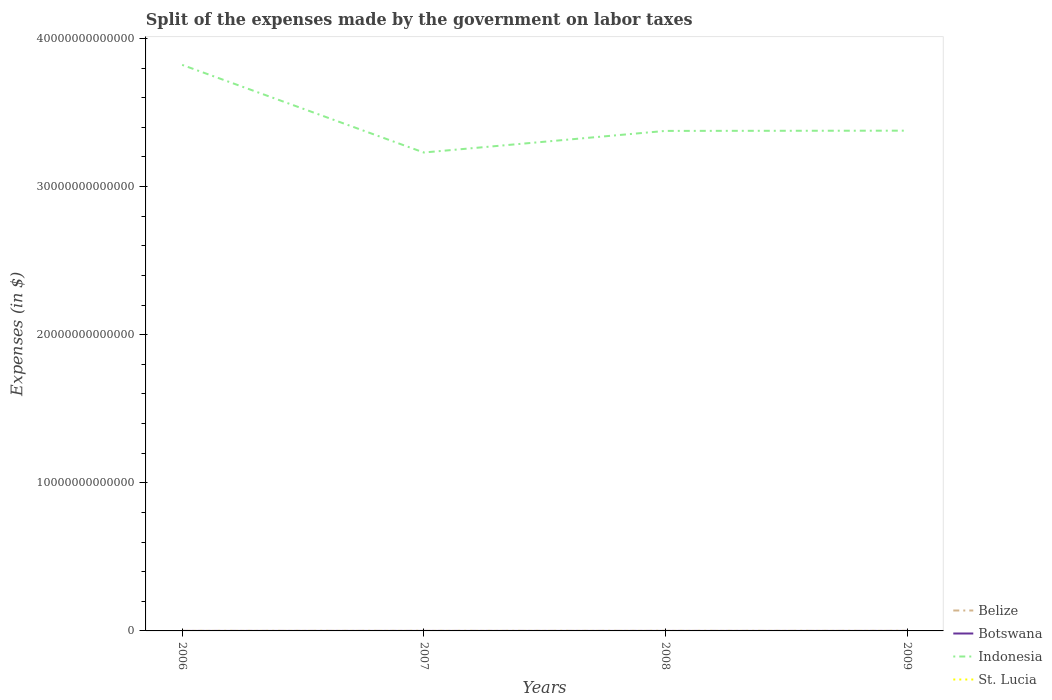Is the number of lines equal to the number of legend labels?
Provide a short and direct response. Yes. Across all years, what is the maximum expenses made by the government on labor taxes in Belize?
Keep it short and to the point. 4.30e+06. In which year was the expenses made by the government on labor taxes in Indonesia maximum?
Your answer should be very brief. 2007. What is the total expenses made by the government on labor taxes in Belize in the graph?
Your response must be concise. -9.65e+05. What is the difference between the highest and the second highest expenses made by the government on labor taxes in Botswana?
Your answer should be very brief. 1.55e+07. What is the difference between the highest and the lowest expenses made by the government on labor taxes in St. Lucia?
Keep it short and to the point. 3. Is the expenses made by the government on labor taxes in St. Lucia strictly greater than the expenses made by the government on labor taxes in Botswana over the years?
Offer a very short reply. Yes. How many years are there in the graph?
Your response must be concise. 4. What is the difference between two consecutive major ticks on the Y-axis?
Give a very brief answer. 1.00e+13. Does the graph contain any zero values?
Your answer should be very brief. No. Does the graph contain grids?
Ensure brevity in your answer.  No. Where does the legend appear in the graph?
Ensure brevity in your answer.  Bottom right. What is the title of the graph?
Keep it short and to the point. Split of the expenses made by the government on labor taxes. Does "Botswana" appear as one of the legend labels in the graph?
Your answer should be very brief. Yes. What is the label or title of the X-axis?
Your answer should be compact. Years. What is the label or title of the Y-axis?
Offer a terse response. Expenses (in $). What is the Expenses (in $) of Belize in 2006?
Your response must be concise. 4.30e+06. What is the Expenses (in $) of Botswana in 2006?
Make the answer very short. 1.71e+07. What is the Expenses (in $) of Indonesia in 2006?
Ensure brevity in your answer.  3.82e+13. What is the Expenses (in $) of St. Lucia in 2006?
Ensure brevity in your answer.  4.70e+06. What is the Expenses (in $) in Belize in 2007?
Your response must be concise. 6.52e+06. What is the Expenses (in $) in Botswana in 2007?
Make the answer very short. 3.26e+07. What is the Expenses (in $) of Indonesia in 2007?
Offer a terse response. 3.23e+13. What is the Expenses (in $) in St. Lucia in 2007?
Ensure brevity in your answer.  4.90e+06. What is the Expenses (in $) of Belize in 2008?
Your answer should be compact. 6.32e+06. What is the Expenses (in $) of Botswana in 2008?
Give a very brief answer. 2.57e+07. What is the Expenses (in $) in Indonesia in 2008?
Offer a terse response. 3.38e+13. What is the Expenses (in $) of St. Lucia in 2008?
Provide a succinct answer. 2.30e+06. What is the Expenses (in $) in Belize in 2009?
Offer a very short reply. 5.26e+06. What is the Expenses (in $) of Botswana in 2009?
Ensure brevity in your answer.  2.73e+07. What is the Expenses (in $) in Indonesia in 2009?
Ensure brevity in your answer.  3.38e+13. What is the Expenses (in $) of St. Lucia in 2009?
Ensure brevity in your answer.  4.20e+06. Across all years, what is the maximum Expenses (in $) in Belize?
Provide a succinct answer. 6.52e+06. Across all years, what is the maximum Expenses (in $) of Botswana?
Your answer should be very brief. 3.26e+07. Across all years, what is the maximum Expenses (in $) in Indonesia?
Offer a very short reply. 3.82e+13. Across all years, what is the maximum Expenses (in $) in St. Lucia?
Your answer should be compact. 4.90e+06. Across all years, what is the minimum Expenses (in $) of Belize?
Keep it short and to the point. 4.30e+06. Across all years, what is the minimum Expenses (in $) of Botswana?
Make the answer very short. 1.71e+07. Across all years, what is the minimum Expenses (in $) in Indonesia?
Keep it short and to the point. 3.23e+13. Across all years, what is the minimum Expenses (in $) of St. Lucia?
Your response must be concise. 2.30e+06. What is the total Expenses (in $) of Belize in the graph?
Provide a short and direct response. 2.24e+07. What is the total Expenses (in $) of Botswana in the graph?
Make the answer very short. 1.03e+08. What is the total Expenses (in $) of Indonesia in the graph?
Your answer should be very brief. 1.38e+14. What is the total Expenses (in $) in St. Lucia in the graph?
Your response must be concise. 1.61e+07. What is the difference between the Expenses (in $) in Belize in 2006 and that in 2007?
Your answer should be very brief. -2.22e+06. What is the difference between the Expenses (in $) in Botswana in 2006 and that in 2007?
Your response must be concise. -1.55e+07. What is the difference between the Expenses (in $) in Indonesia in 2006 and that in 2007?
Give a very brief answer. 5.92e+12. What is the difference between the Expenses (in $) of Belize in 2006 and that in 2008?
Make the answer very short. -2.03e+06. What is the difference between the Expenses (in $) in Botswana in 2006 and that in 2008?
Ensure brevity in your answer.  -8.63e+06. What is the difference between the Expenses (in $) of Indonesia in 2006 and that in 2008?
Keep it short and to the point. 4.46e+12. What is the difference between the Expenses (in $) in St. Lucia in 2006 and that in 2008?
Your answer should be very brief. 2.40e+06. What is the difference between the Expenses (in $) in Belize in 2006 and that in 2009?
Give a very brief answer. -9.65e+05. What is the difference between the Expenses (in $) in Botswana in 2006 and that in 2009?
Offer a terse response. -1.02e+07. What is the difference between the Expenses (in $) in Indonesia in 2006 and that in 2009?
Your answer should be very brief. 4.44e+12. What is the difference between the Expenses (in $) in St. Lucia in 2006 and that in 2009?
Your response must be concise. 5.00e+05. What is the difference between the Expenses (in $) in Belize in 2007 and that in 2008?
Your response must be concise. 1.98e+05. What is the difference between the Expenses (in $) in Botswana in 2007 and that in 2008?
Give a very brief answer. 6.88e+06. What is the difference between the Expenses (in $) of Indonesia in 2007 and that in 2008?
Provide a succinct answer. -1.46e+12. What is the difference between the Expenses (in $) of St. Lucia in 2007 and that in 2008?
Offer a terse response. 2.60e+06. What is the difference between the Expenses (in $) in Belize in 2007 and that in 2009?
Keep it short and to the point. 1.26e+06. What is the difference between the Expenses (in $) in Botswana in 2007 and that in 2009?
Offer a very short reply. 5.31e+06. What is the difference between the Expenses (in $) in Indonesia in 2007 and that in 2009?
Offer a terse response. -1.48e+12. What is the difference between the Expenses (in $) in St. Lucia in 2007 and that in 2009?
Ensure brevity in your answer.  7.00e+05. What is the difference between the Expenses (in $) of Belize in 2008 and that in 2009?
Make the answer very short. 1.06e+06. What is the difference between the Expenses (in $) in Botswana in 2008 and that in 2009?
Your response must be concise. -1.57e+06. What is the difference between the Expenses (in $) of Indonesia in 2008 and that in 2009?
Your answer should be compact. -1.61e+1. What is the difference between the Expenses (in $) of St. Lucia in 2008 and that in 2009?
Offer a terse response. -1.90e+06. What is the difference between the Expenses (in $) in Belize in 2006 and the Expenses (in $) in Botswana in 2007?
Make the answer very short. -2.83e+07. What is the difference between the Expenses (in $) of Belize in 2006 and the Expenses (in $) of Indonesia in 2007?
Make the answer very short. -3.23e+13. What is the difference between the Expenses (in $) in Belize in 2006 and the Expenses (in $) in St. Lucia in 2007?
Offer a very short reply. -6.03e+05. What is the difference between the Expenses (in $) in Botswana in 2006 and the Expenses (in $) in Indonesia in 2007?
Your response must be concise. -3.23e+13. What is the difference between the Expenses (in $) of Botswana in 2006 and the Expenses (in $) of St. Lucia in 2007?
Keep it short and to the point. 1.22e+07. What is the difference between the Expenses (in $) of Indonesia in 2006 and the Expenses (in $) of St. Lucia in 2007?
Provide a succinct answer. 3.82e+13. What is the difference between the Expenses (in $) of Belize in 2006 and the Expenses (in $) of Botswana in 2008?
Give a very brief answer. -2.14e+07. What is the difference between the Expenses (in $) of Belize in 2006 and the Expenses (in $) of Indonesia in 2008?
Keep it short and to the point. -3.38e+13. What is the difference between the Expenses (in $) of Belize in 2006 and the Expenses (in $) of St. Lucia in 2008?
Offer a terse response. 2.00e+06. What is the difference between the Expenses (in $) of Botswana in 2006 and the Expenses (in $) of Indonesia in 2008?
Your answer should be compact. -3.38e+13. What is the difference between the Expenses (in $) in Botswana in 2006 and the Expenses (in $) in St. Lucia in 2008?
Your response must be concise. 1.48e+07. What is the difference between the Expenses (in $) of Indonesia in 2006 and the Expenses (in $) of St. Lucia in 2008?
Make the answer very short. 3.82e+13. What is the difference between the Expenses (in $) in Belize in 2006 and the Expenses (in $) in Botswana in 2009?
Your answer should be compact. -2.30e+07. What is the difference between the Expenses (in $) of Belize in 2006 and the Expenses (in $) of Indonesia in 2009?
Keep it short and to the point. -3.38e+13. What is the difference between the Expenses (in $) of Belize in 2006 and the Expenses (in $) of St. Lucia in 2009?
Give a very brief answer. 9.70e+04. What is the difference between the Expenses (in $) of Botswana in 2006 and the Expenses (in $) of Indonesia in 2009?
Give a very brief answer. -3.38e+13. What is the difference between the Expenses (in $) of Botswana in 2006 and the Expenses (in $) of St. Lucia in 2009?
Keep it short and to the point. 1.29e+07. What is the difference between the Expenses (in $) in Indonesia in 2006 and the Expenses (in $) in St. Lucia in 2009?
Keep it short and to the point. 3.82e+13. What is the difference between the Expenses (in $) in Belize in 2007 and the Expenses (in $) in Botswana in 2008?
Keep it short and to the point. -1.92e+07. What is the difference between the Expenses (in $) of Belize in 2007 and the Expenses (in $) of Indonesia in 2008?
Your response must be concise. -3.38e+13. What is the difference between the Expenses (in $) of Belize in 2007 and the Expenses (in $) of St. Lucia in 2008?
Provide a short and direct response. 4.22e+06. What is the difference between the Expenses (in $) in Botswana in 2007 and the Expenses (in $) in Indonesia in 2008?
Your answer should be very brief. -3.38e+13. What is the difference between the Expenses (in $) in Botswana in 2007 and the Expenses (in $) in St. Lucia in 2008?
Ensure brevity in your answer.  3.03e+07. What is the difference between the Expenses (in $) in Indonesia in 2007 and the Expenses (in $) in St. Lucia in 2008?
Your answer should be compact. 3.23e+13. What is the difference between the Expenses (in $) of Belize in 2007 and the Expenses (in $) of Botswana in 2009?
Offer a terse response. -2.08e+07. What is the difference between the Expenses (in $) in Belize in 2007 and the Expenses (in $) in Indonesia in 2009?
Give a very brief answer. -3.38e+13. What is the difference between the Expenses (in $) in Belize in 2007 and the Expenses (in $) in St. Lucia in 2009?
Provide a succinct answer. 2.32e+06. What is the difference between the Expenses (in $) in Botswana in 2007 and the Expenses (in $) in Indonesia in 2009?
Keep it short and to the point. -3.38e+13. What is the difference between the Expenses (in $) in Botswana in 2007 and the Expenses (in $) in St. Lucia in 2009?
Offer a terse response. 2.84e+07. What is the difference between the Expenses (in $) of Indonesia in 2007 and the Expenses (in $) of St. Lucia in 2009?
Keep it short and to the point. 3.23e+13. What is the difference between the Expenses (in $) of Belize in 2008 and the Expenses (in $) of Botswana in 2009?
Your answer should be very brief. -2.10e+07. What is the difference between the Expenses (in $) in Belize in 2008 and the Expenses (in $) in Indonesia in 2009?
Your answer should be compact. -3.38e+13. What is the difference between the Expenses (in $) in Belize in 2008 and the Expenses (in $) in St. Lucia in 2009?
Keep it short and to the point. 2.12e+06. What is the difference between the Expenses (in $) of Botswana in 2008 and the Expenses (in $) of Indonesia in 2009?
Ensure brevity in your answer.  -3.38e+13. What is the difference between the Expenses (in $) in Botswana in 2008 and the Expenses (in $) in St. Lucia in 2009?
Your answer should be very brief. 2.15e+07. What is the difference between the Expenses (in $) in Indonesia in 2008 and the Expenses (in $) in St. Lucia in 2009?
Keep it short and to the point. 3.38e+13. What is the average Expenses (in $) of Belize per year?
Provide a short and direct response. 5.60e+06. What is the average Expenses (in $) of Botswana per year?
Your response must be concise. 2.57e+07. What is the average Expenses (in $) in Indonesia per year?
Your response must be concise. 3.45e+13. What is the average Expenses (in $) of St. Lucia per year?
Provide a succinct answer. 4.02e+06. In the year 2006, what is the difference between the Expenses (in $) in Belize and Expenses (in $) in Botswana?
Your answer should be compact. -1.28e+07. In the year 2006, what is the difference between the Expenses (in $) of Belize and Expenses (in $) of Indonesia?
Provide a succinct answer. -3.82e+13. In the year 2006, what is the difference between the Expenses (in $) of Belize and Expenses (in $) of St. Lucia?
Give a very brief answer. -4.03e+05. In the year 2006, what is the difference between the Expenses (in $) in Botswana and Expenses (in $) in Indonesia?
Ensure brevity in your answer.  -3.82e+13. In the year 2006, what is the difference between the Expenses (in $) of Botswana and Expenses (in $) of St. Lucia?
Offer a very short reply. 1.24e+07. In the year 2006, what is the difference between the Expenses (in $) of Indonesia and Expenses (in $) of St. Lucia?
Ensure brevity in your answer.  3.82e+13. In the year 2007, what is the difference between the Expenses (in $) in Belize and Expenses (in $) in Botswana?
Ensure brevity in your answer.  -2.61e+07. In the year 2007, what is the difference between the Expenses (in $) of Belize and Expenses (in $) of Indonesia?
Provide a succinct answer. -3.23e+13. In the year 2007, what is the difference between the Expenses (in $) in Belize and Expenses (in $) in St. Lucia?
Your response must be concise. 1.62e+06. In the year 2007, what is the difference between the Expenses (in $) in Botswana and Expenses (in $) in Indonesia?
Your answer should be compact. -3.23e+13. In the year 2007, what is the difference between the Expenses (in $) in Botswana and Expenses (in $) in St. Lucia?
Your response must be concise. 2.77e+07. In the year 2007, what is the difference between the Expenses (in $) of Indonesia and Expenses (in $) of St. Lucia?
Your response must be concise. 3.23e+13. In the year 2008, what is the difference between the Expenses (in $) of Belize and Expenses (in $) of Botswana?
Keep it short and to the point. -1.94e+07. In the year 2008, what is the difference between the Expenses (in $) in Belize and Expenses (in $) in Indonesia?
Your response must be concise. -3.38e+13. In the year 2008, what is the difference between the Expenses (in $) in Belize and Expenses (in $) in St. Lucia?
Offer a very short reply. 4.02e+06. In the year 2008, what is the difference between the Expenses (in $) of Botswana and Expenses (in $) of Indonesia?
Offer a very short reply. -3.38e+13. In the year 2008, what is the difference between the Expenses (in $) of Botswana and Expenses (in $) of St. Lucia?
Make the answer very short. 2.34e+07. In the year 2008, what is the difference between the Expenses (in $) of Indonesia and Expenses (in $) of St. Lucia?
Provide a short and direct response. 3.38e+13. In the year 2009, what is the difference between the Expenses (in $) in Belize and Expenses (in $) in Botswana?
Offer a terse response. -2.20e+07. In the year 2009, what is the difference between the Expenses (in $) of Belize and Expenses (in $) of Indonesia?
Your answer should be compact. -3.38e+13. In the year 2009, what is the difference between the Expenses (in $) of Belize and Expenses (in $) of St. Lucia?
Offer a terse response. 1.06e+06. In the year 2009, what is the difference between the Expenses (in $) of Botswana and Expenses (in $) of Indonesia?
Your response must be concise. -3.38e+13. In the year 2009, what is the difference between the Expenses (in $) of Botswana and Expenses (in $) of St. Lucia?
Give a very brief answer. 2.31e+07. In the year 2009, what is the difference between the Expenses (in $) in Indonesia and Expenses (in $) in St. Lucia?
Offer a terse response. 3.38e+13. What is the ratio of the Expenses (in $) in Belize in 2006 to that in 2007?
Provide a short and direct response. 0.66. What is the ratio of the Expenses (in $) in Botswana in 2006 to that in 2007?
Offer a very short reply. 0.52. What is the ratio of the Expenses (in $) of Indonesia in 2006 to that in 2007?
Provide a short and direct response. 1.18. What is the ratio of the Expenses (in $) of St. Lucia in 2006 to that in 2007?
Make the answer very short. 0.96. What is the ratio of the Expenses (in $) of Belize in 2006 to that in 2008?
Provide a short and direct response. 0.68. What is the ratio of the Expenses (in $) in Botswana in 2006 to that in 2008?
Give a very brief answer. 0.66. What is the ratio of the Expenses (in $) in Indonesia in 2006 to that in 2008?
Provide a succinct answer. 1.13. What is the ratio of the Expenses (in $) in St. Lucia in 2006 to that in 2008?
Offer a very short reply. 2.04. What is the ratio of the Expenses (in $) in Belize in 2006 to that in 2009?
Provide a succinct answer. 0.82. What is the ratio of the Expenses (in $) in Botswana in 2006 to that in 2009?
Offer a terse response. 0.63. What is the ratio of the Expenses (in $) in Indonesia in 2006 to that in 2009?
Provide a succinct answer. 1.13. What is the ratio of the Expenses (in $) of St. Lucia in 2006 to that in 2009?
Provide a short and direct response. 1.12. What is the ratio of the Expenses (in $) of Belize in 2007 to that in 2008?
Offer a very short reply. 1.03. What is the ratio of the Expenses (in $) in Botswana in 2007 to that in 2008?
Your response must be concise. 1.27. What is the ratio of the Expenses (in $) of Indonesia in 2007 to that in 2008?
Provide a short and direct response. 0.96. What is the ratio of the Expenses (in $) of St. Lucia in 2007 to that in 2008?
Keep it short and to the point. 2.13. What is the ratio of the Expenses (in $) in Belize in 2007 to that in 2009?
Make the answer very short. 1.24. What is the ratio of the Expenses (in $) in Botswana in 2007 to that in 2009?
Keep it short and to the point. 1.19. What is the ratio of the Expenses (in $) in Indonesia in 2007 to that in 2009?
Your response must be concise. 0.96. What is the ratio of the Expenses (in $) in St. Lucia in 2007 to that in 2009?
Your response must be concise. 1.17. What is the ratio of the Expenses (in $) in Belize in 2008 to that in 2009?
Your answer should be compact. 1.2. What is the ratio of the Expenses (in $) of Botswana in 2008 to that in 2009?
Ensure brevity in your answer.  0.94. What is the ratio of the Expenses (in $) of Indonesia in 2008 to that in 2009?
Your answer should be compact. 1. What is the ratio of the Expenses (in $) in St. Lucia in 2008 to that in 2009?
Offer a terse response. 0.55. What is the difference between the highest and the second highest Expenses (in $) in Belize?
Keep it short and to the point. 1.98e+05. What is the difference between the highest and the second highest Expenses (in $) of Botswana?
Make the answer very short. 5.31e+06. What is the difference between the highest and the second highest Expenses (in $) in Indonesia?
Provide a short and direct response. 4.44e+12. What is the difference between the highest and the lowest Expenses (in $) of Belize?
Your answer should be very brief. 2.22e+06. What is the difference between the highest and the lowest Expenses (in $) in Botswana?
Provide a short and direct response. 1.55e+07. What is the difference between the highest and the lowest Expenses (in $) of Indonesia?
Offer a very short reply. 5.92e+12. What is the difference between the highest and the lowest Expenses (in $) of St. Lucia?
Offer a very short reply. 2.60e+06. 